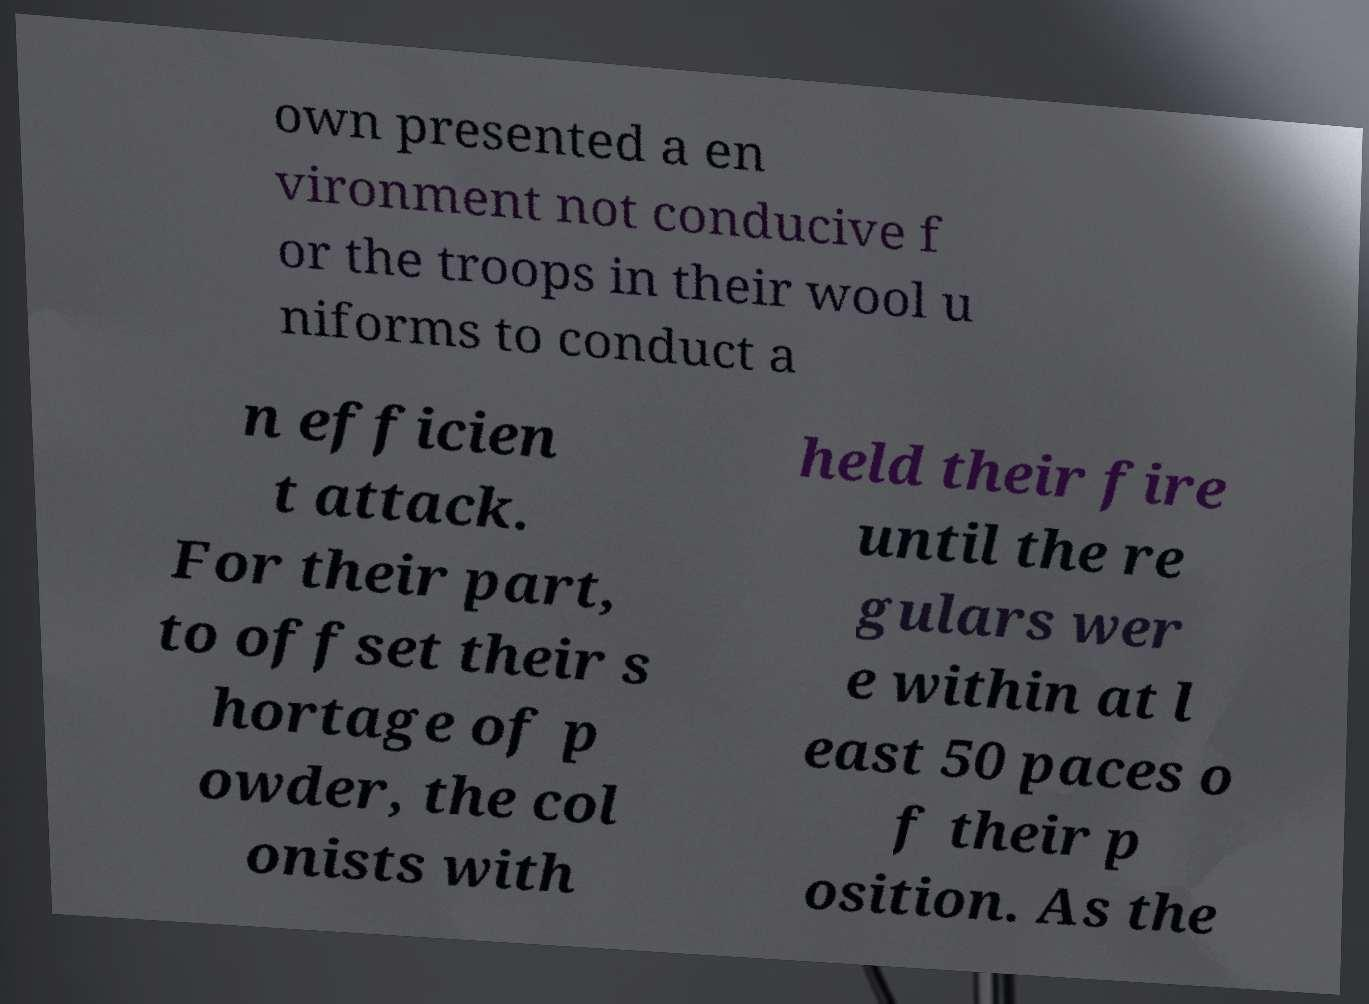What messages or text are displayed in this image? I need them in a readable, typed format. own presented a en vironment not conducive f or the troops in their wool u niforms to conduct a n efficien t attack. For their part, to offset their s hortage of p owder, the col onists with held their fire until the re gulars wer e within at l east 50 paces o f their p osition. As the 